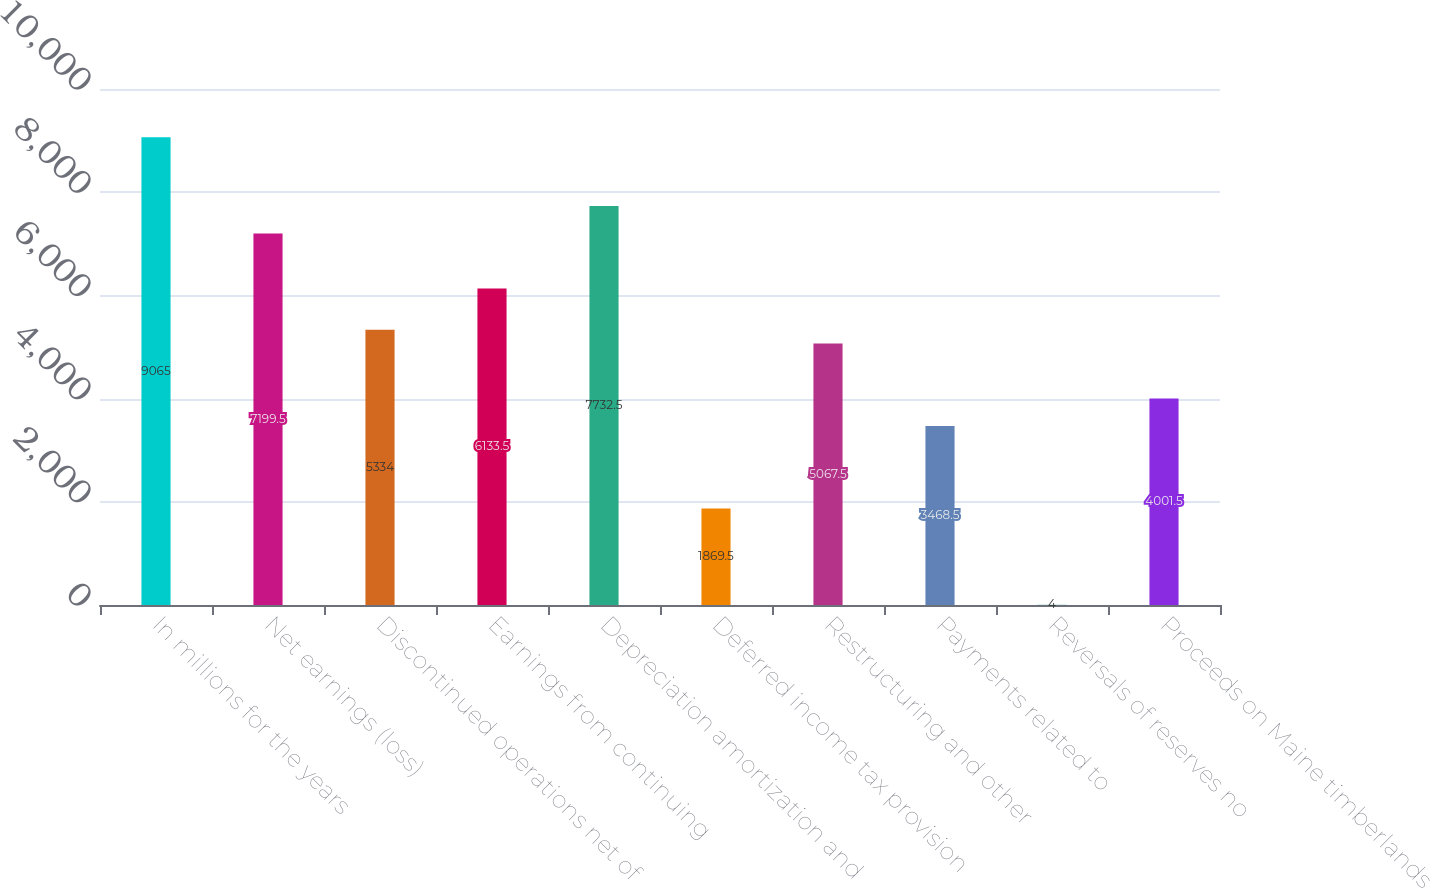Convert chart. <chart><loc_0><loc_0><loc_500><loc_500><bar_chart><fcel>In millions for the years<fcel>Net earnings (loss)<fcel>Discontinued operations net of<fcel>Earnings from continuing<fcel>Depreciation amortization and<fcel>Deferred income tax provision<fcel>Restructuring and other<fcel>Payments related to<fcel>Reversals of reserves no<fcel>Proceeds on Maine timberlands<nl><fcel>9065<fcel>7199.5<fcel>5334<fcel>6133.5<fcel>7732.5<fcel>1869.5<fcel>5067.5<fcel>3468.5<fcel>4<fcel>4001.5<nl></chart> 